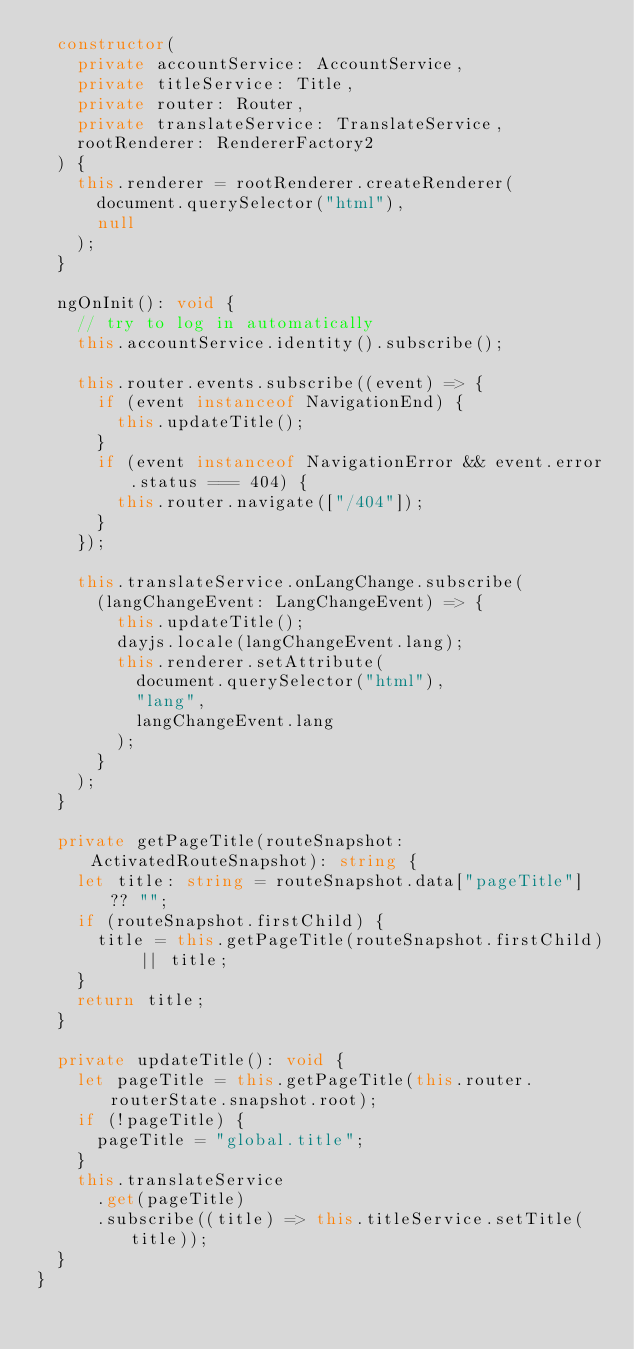Convert code to text. <code><loc_0><loc_0><loc_500><loc_500><_TypeScript_>  constructor(
    private accountService: AccountService,
    private titleService: Title,
    private router: Router,
    private translateService: TranslateService,
    rootRenderer: RendererFactory2
  ) {
    this.renderer = rootRenderer.createRenderer(
      document.querySelector("html"),
      null
    );
  }

  ngOnInit(): void {
    // try to log in automatically
    this.accountService.identity().subscribe();

    this.router.events.subscribe((event) => {
      if (event instanceof NavigationEnd) {
        this.updateTitle();
      }
      if (event instanceof NavigationError && event.error.status === 404) {
        this.router.navigate(["/404"]);
      }
    });

    this.translateService.onLangChange.subscribe(
      (langChangeEvent: LangChangeEvent) => {
        this.updateTitle();
        dayjs.locale(langChangeEvent.lang);
        this.renderer.setAttribute(
          document.querySelector("html"),
          "lang",
          langChangeEvent.lang
        );
      }
    );
  }

  private getPageTitle(routeSnapshot: ActivatedRouteSnapshot): string {
    let title: string = routeSnapshot.data["pageTitle"] ?? "";
    if (routeSnapshot.firstChild) {
      title = this.getPageTitle(routeSnapshot.firstChild) || title;
    }
    return title;
  }

  private updateTitle(): void {
    let pageTitle = this.getPageTitle(this.router.routerState.snapshot.root);
    if (!pageTitle) {
      pageTitle = "global.title";
    }
    this.translateService
      .get(pageTitle)
      .subscribe((title) => this.titleService.setTitle(title));
  }
}
</code> 